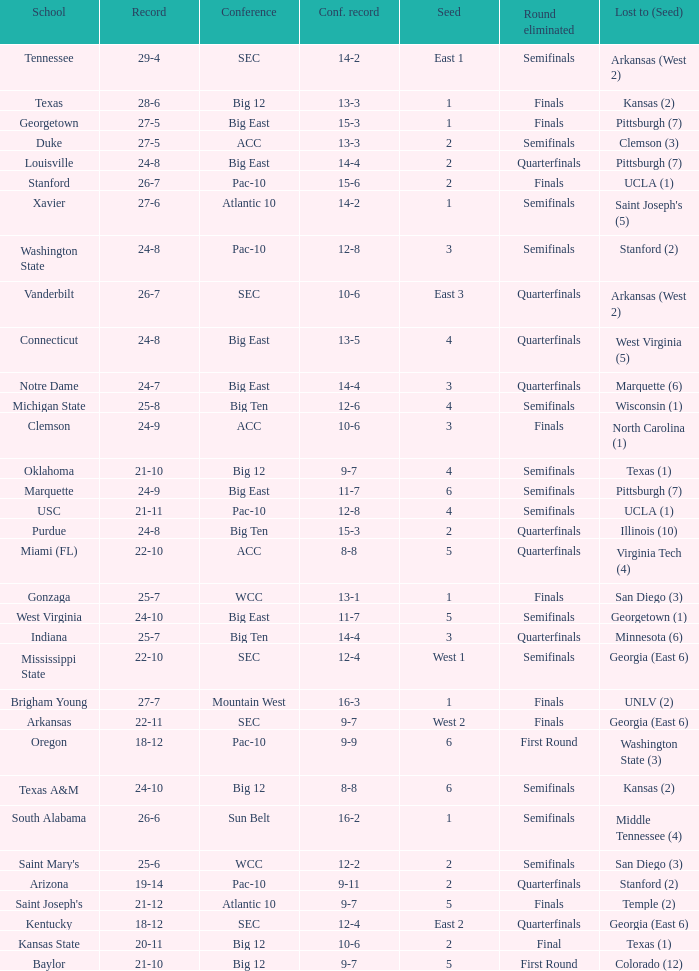Name the school where conference record is 12-6 Michigan State. Give me the full table as a dictionary. {'header': ['School', 'Record', 'Conference', 'Conf. record', 'Seed', 'Round eliminated', 'Lost to (Seed)'], 'rows': [['Tennessee', '29-4', 'SEC', '14-2', 'East 1', 'Semifinals', 'Arkansas (West 2)'], ['Texas', '28-6', 'Big 12', '13-3', '1', 'Finals', 'Kansas (2)'], ['Georgetown', '27-5', 'Big East', '15-3', '1', 'Finals', 'Pittsburgh (7)'], ['Duke', '27-5', 'ACC', '13-3', '2', 'Semifinals', 'Clemson (3)'], ['Louisville', '24-8', 'Big East', '14-4', '2', 'Quarterfinals', 'Pittsburgh (7)'], ['Stanford', '26-7', 'Pac-10', '15-6', '2', 'Finals', 'UCLA (1)'], ['Xavier', '27-6', 'Atlantic 10', '14-2', '1', 'Semifinals', "Saint Joseph's (5)"], ['Washington State', '24-8', 'Pac-10', '12-8', '3', 'Semifinals', 'Stanford (2)'], ['Vanderbilt', '26-7', 'SEC', '10-6', 'East 3', 'Quarterfinals', 'Arkansas (West 2)'], ['Connecticut', '24-8', 'Big East', '13-5', '4', 'Quarterfinals', 'West Virginia (5)'], ['Notre Dame', '24-7', 'Big East', '14-4', '3', 'Quarterfinals', 'Marquette (6)'], ['Michigan State', '25-8', 'Big Ten', '12-6', '4', 'Semifinals', 'Wisconsin (1)'], ['Clemson', '24-9', 'ACC', '10-6', '3', 'Finals', 'North Carolina (1)'], ['Oklahoma', '21-10', 'Big 12', '9-7', '4', 'Semifinals', 'Texas (1)'], ['Marquette', '24-9', 'Big East', '11-7', '6', 'Semifinals', 'Pittsburgh (7)'], ['USC', '21-11', 'Pac-10', '12-8', '4', 'Semifinals', 'UCLA (1)'], ['Purdue', '24-8', 'Big Ten', '15-3', '2', 'Quarterfinals', 'Illinois (10)'], ['Miami (FL)', '22-10', 'ACC', '8-8', '5', 'Quarterfinals', 'Virginia Tech (4)'], ['Gonzaga', '25-7', 'WCC', '13-1', '1', 'Finals', 'San Diego (3)'], ['West Virginia', '24-10', 'Big East', '11-7', '5', 'Semifinals', 'Georgetown (1)'], ['Indiana', '25-7', 'Big Ten', '14-4', '3', 'Quarterfinals', 'Minnesota (6)'], ['Mississippi State', '22-10', 'SEC', '12-4', 'West 1', 'Semifinals', 'Georgia (East 6)'], ['Brigham Young', '27-7', 'Mountain West', '16-3', '1', 'Finals', 'UNLV (2)'], ['Arkansas', '22-11', 'SEC', '9-7', 'West 2', 'Finals', 'Georgia (East 6)'], ['Oregon', '18-12', 'Pac-10', '9-9', '6', 'First Round', 'Washington State (3)'], ['Texas A&M', '24-10', 'Big 12', '8-8', '6', 'Semifinals', 'Kansas (2)'], ['South Alabama', '26-6', 'Sun Belt', '16-2', '1', 'Semifinals', 'Middle Tennessee (4)'], ["Saint Mary's", '25-6', 'WCC', '12-2', '2', 'Semifinals', 'San Diego (3)'], ['Arizona', '19-14', 'Pac-10', '9-11', '2', 'Quarterfinals', 'Stanford (2)'], ["Saint Joseph's", '21-12', 'Atlantic 10', '9-7', '5', 'Finals', 'Temple (2)'], ['Kentucky', '18-12', 'SEC', '12-4', 'East 2', 'Quarterfinals', 'Georgia (East 6)'], ['Kansas State', '20-11', 'Big 12', '10-6', '2', 'Final', 'Texas (1)'], ['Baylor', '21-10', 'Big 12', '9-7', '5', 'First Round', 'Colorado (12)']]} 